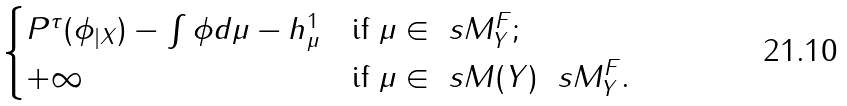<formula> <loc_0><loc_0><loc_500><loc_500>\begin{cases} P ^ { \tau } ( \phi _ { | X } ) - \int \phi d \mu - h ^ { 1 } _ { \mu } & \text {if } \mu \in \ s M ^ { F } _ { Y } ; \\ + \infty & \text {if } \mu \in \ s M ( Y ) \ \ s M ^ { F } _ { Y } . \end{cases}</formula> 